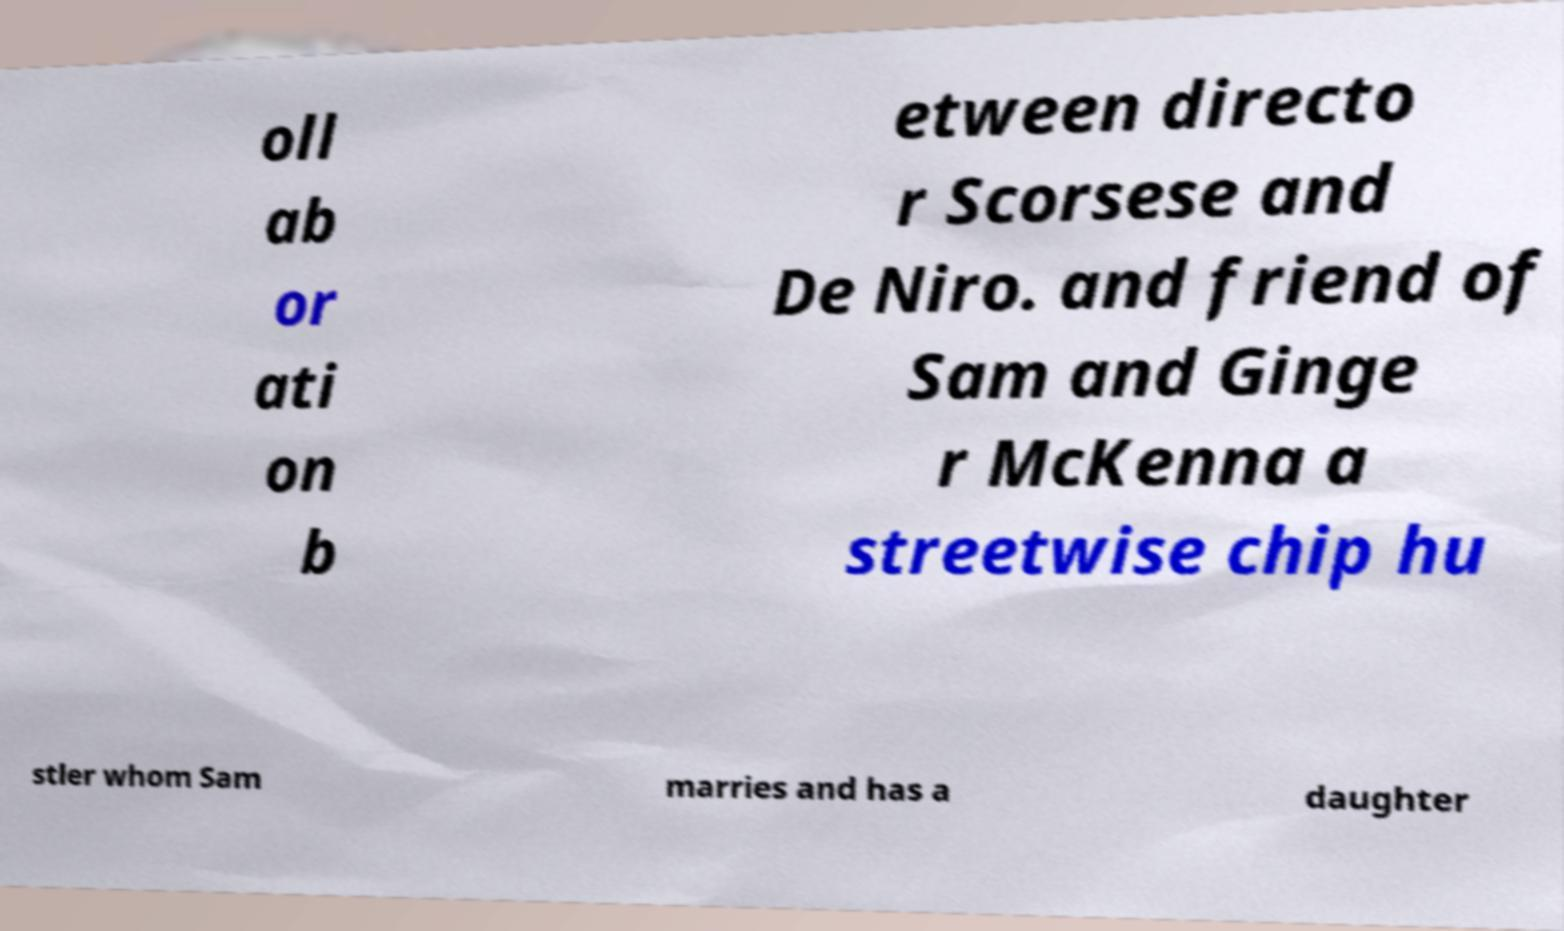Please identify and transcribe the text found in this image. oll ab or ati on b etween directo r Scorsese and De Niro. and friend of Sam and Ginge r McKenna a streetwise chip hu stler whom Sam marries and has a daughter 